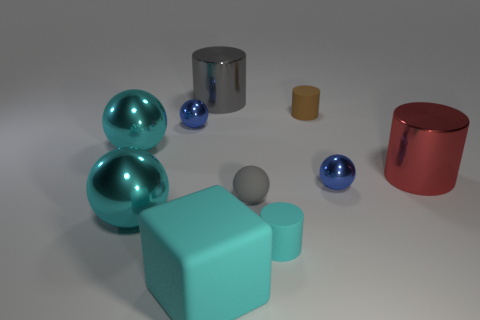The large cylinder that is the same material as the big red thing is what color? gray 